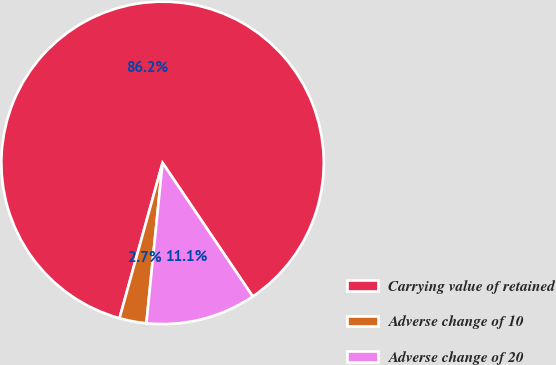<chart> <loc_0><loc_0><loc_500><loc_500><pie_chart><fcel>Carrying value of retained<fcel>Adverse change of 10<fcel>Adverse change of 20<nl><fcel>86.25%<fcel>2.7%<fcel>11.05%<nl></chart> 